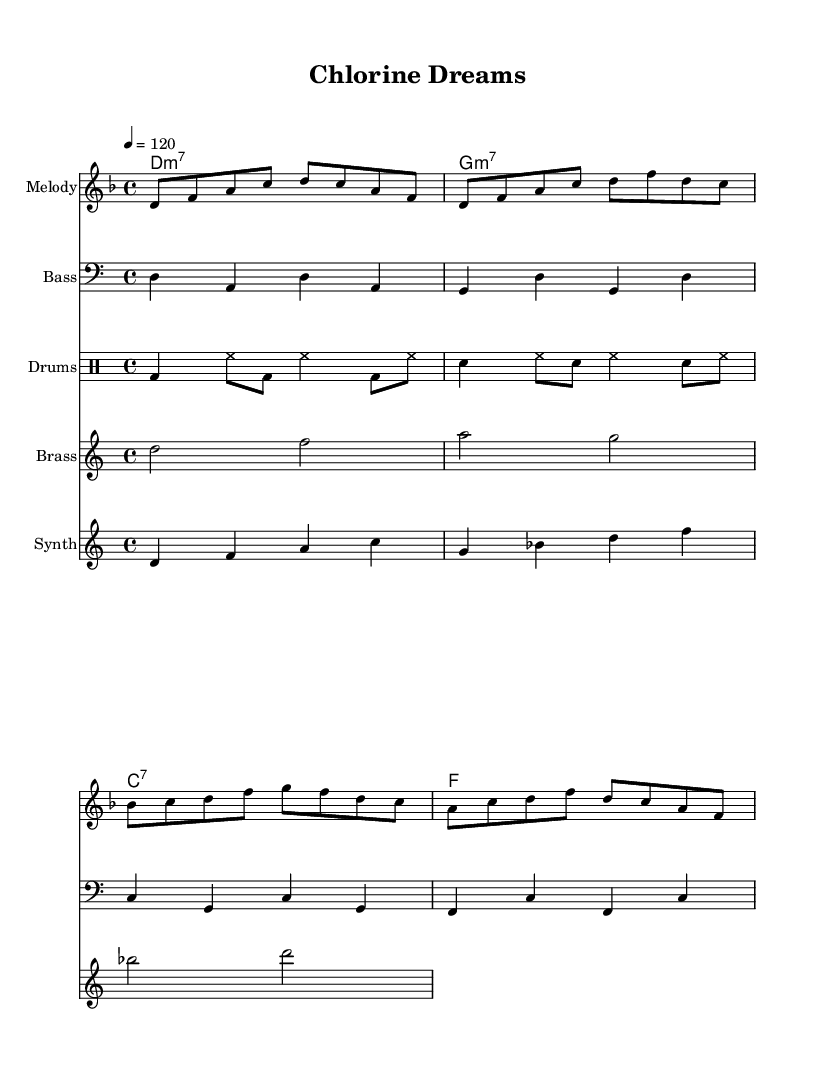What is the key signature of this music? The key signature shown at the beginning of the score is two flats, indicating B-flat major or G minor. Since the piece is in D minor, we recognize that D minor has one flat, making the key signature relevant to the overall harmonic context.
Answer: D minor What is the time signature of this music? The time signature displayed at the beginning of the score is 4/4. This means there are four beats in each measure and a quarter note receives one beat, which is common in Funk music.
Answer: 4/4 What is the tempo marking for this piece? At the start of the music, the tempo marking is set to a quarter note equals 120 beats per minute, indicating a moderate and steady pace typical for Funk tracks.
Answer: 120 How many measures are there in the melody? By counting the individual groups of notes separated by vertical bar lines in the melody, we find there are a total of four measures, reflecting a common phrase structure in Funk music.
Answer: 4 What instrument is used for the synth part? The score explicitly labels the staff as "Synth," distinguishing it as the synthesizer part which adds a distinct texture typical in Funk genre pieces.
Answer: Synth Which chords are used in the harmonies? The chords listed under the harmonies section are D minor seven, G minor seven, C dominant seven, and F major, illustrating the classic chord progression associated with Funk music.
Answer: D minor seven, G minor seven, C dominant seven, F major What is the main theme of the lyrics? The lyrics reflect nostalgic feelings about swimming and success during the 1970s, capturing the essence of the song's title "Chlorine Dreams" and connecting it to Olympic achievements.
Answer: Nostalgia for swimming 